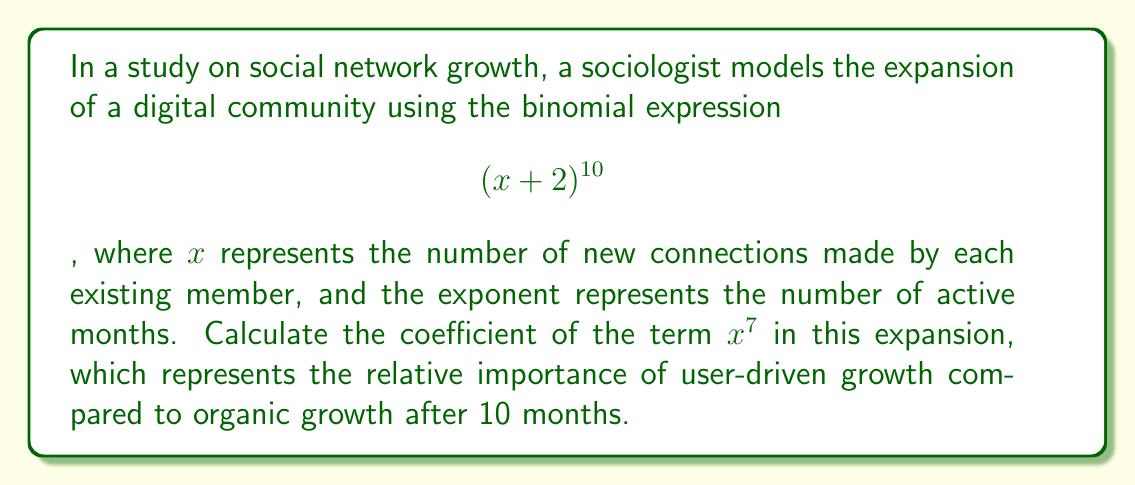Solve this math problem. To find the coefficient of $x^7$ in $(x + 2)^{10}$, we can use the binomial theorem:

1) The general term in the expansion is given by:
   $$\binom{10}{k}x^k2^{10-k}$$

2) For the $x^7$ term, $k = 7$. So we need to calculate:
   $$\binom{10}{7}x^72^3$$

3) The binomial coefficient $\binom{10}{7}$ is calculated as:
   $$\binom{10}{7} = \frac{10!}{7!(10-7)!} = \frac{10!}{7!3!}$$

4) Expand this:
   $$\frac{10 \cdot 9 \cdot 8 \cdot 7!}{7! \cdot 3 \cdot 2 \cdot 1} = \frac{720}{6} = 120$$

5) Now, we have:
   $$120 \cdot x^7 \cdot 2^3 = 120 \cdot x^7 \cdot 8 = 960x^7$$

6) Therefore, the coefficient of $x^7$ is 960.

This coefficient represents the relative importance of user-driven growth (represented by $x^7$) compared to organic growth (represented by the remaining terms) after 10 months in this social network model.
Answer: 960 